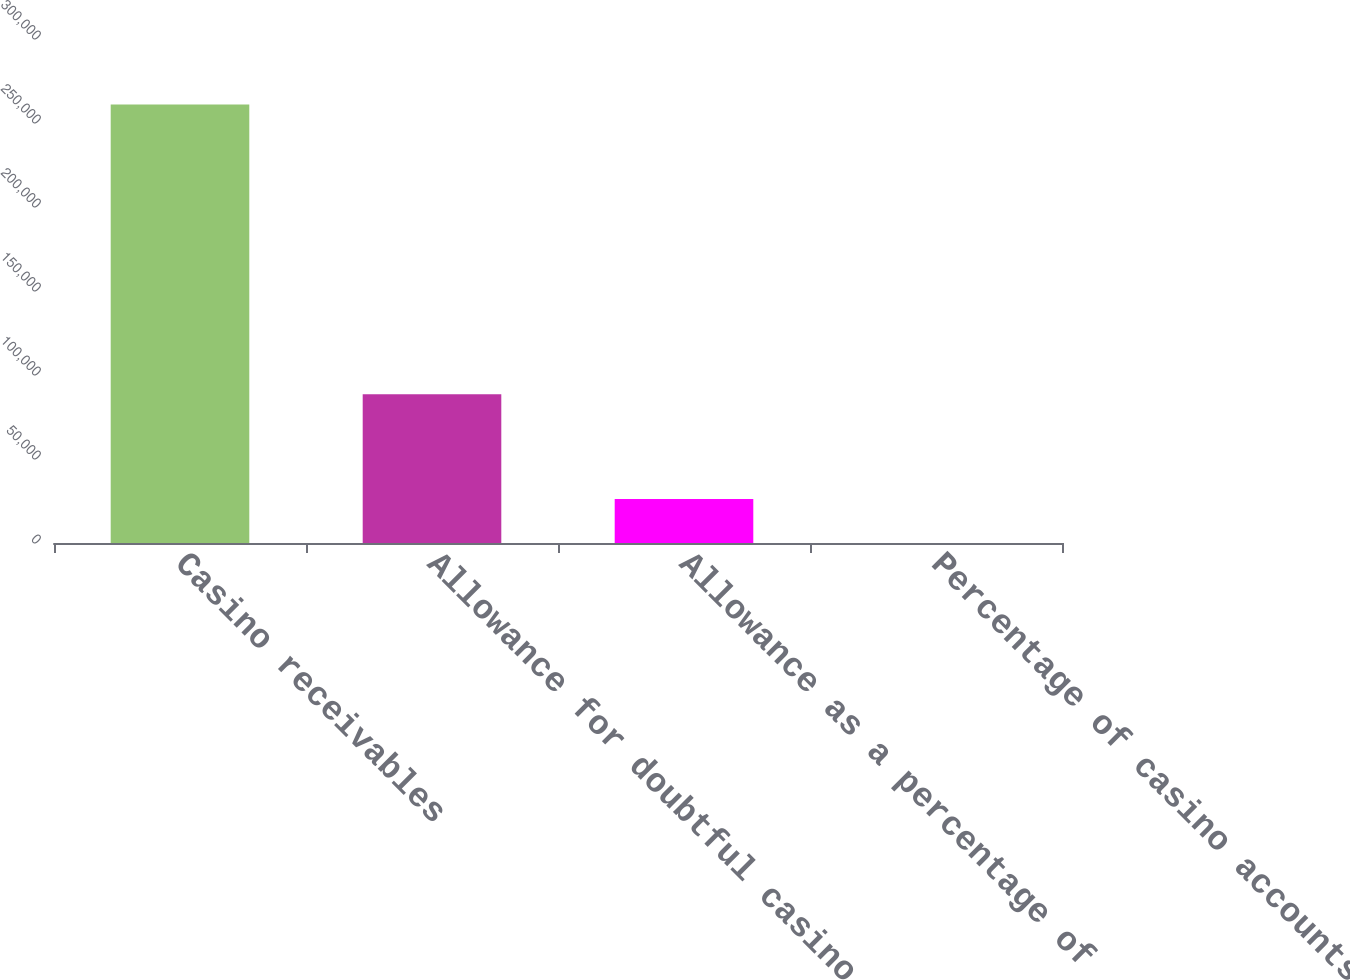<chart> <loc_0><loc_0><loc_500><loc_500><bar_chart><fcel>Casino receivables<fcel>Allowance for doubtful casino<fcel>Allowance as a percentage of<fcel>Percentage of casino accounts<nl><fcel>261025<fcel>88557<fcel>26124.1<fcel>24<nl></chart> 